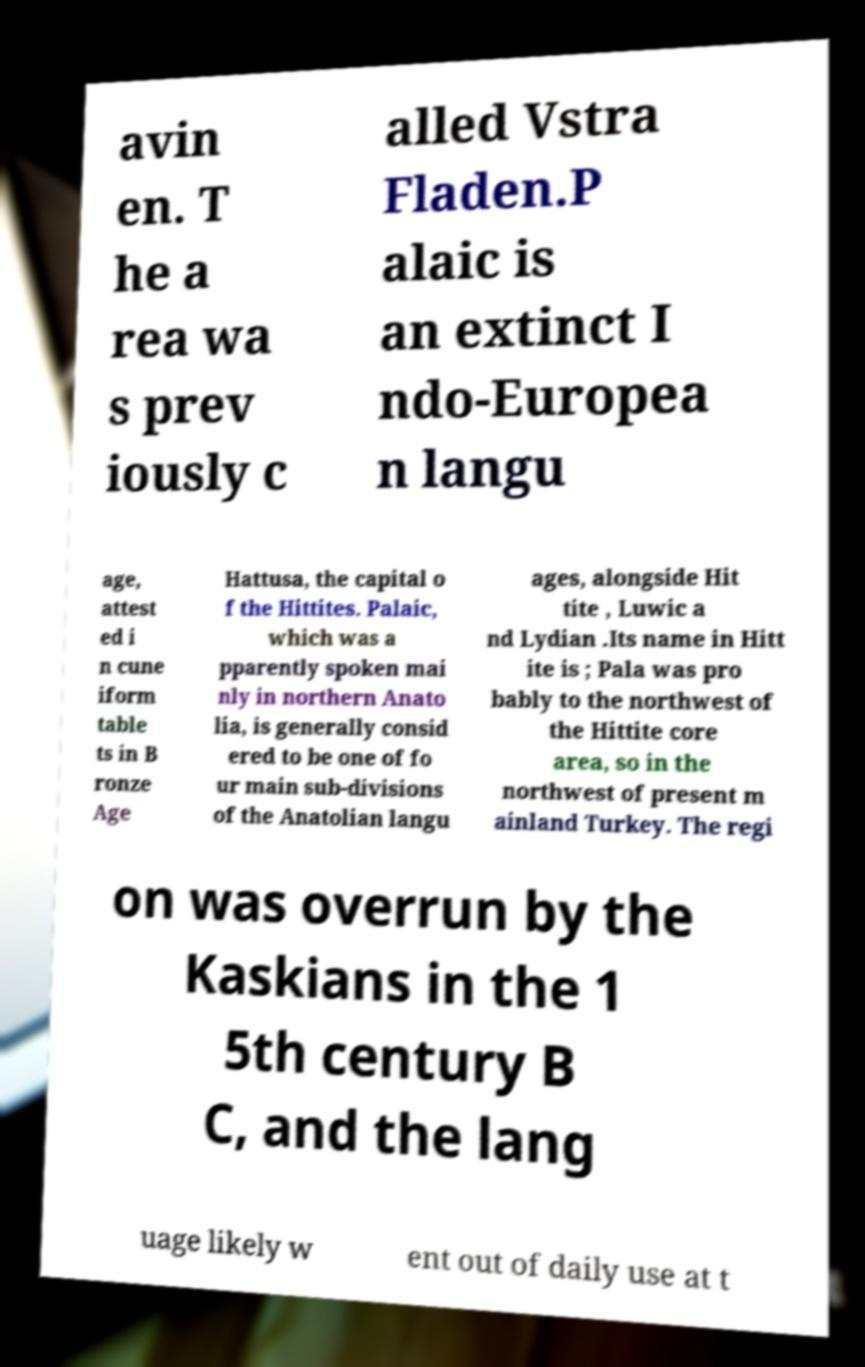For documentation purposes, I need the text within this image transcribed. Could you provide that? avin en. T he a rea wa s prev iously c alled Vstra Fladen.P alaic is an extinct I ndo-Europea n langu age, attest ed i n cune iform table ts in B ronze Age Hattusa, the capital o f the Hittites. Palaic, which was a pparently spoken mai nly in northern Anato lia, is generally consid ered to be one of fo ur main sub-divisions of the Anatolian langu ages, alongside Hit tite , Luwic a nd Lydian .Its name in Hitt ite is ; Pala was pro bably to the northwest of the Hittite core area, so in the northwest of present m ainland Turkey. The regi on was overrun by the Kaskians in the 1 5th century B C, and the lang uage likely w ent out of daily use at t 